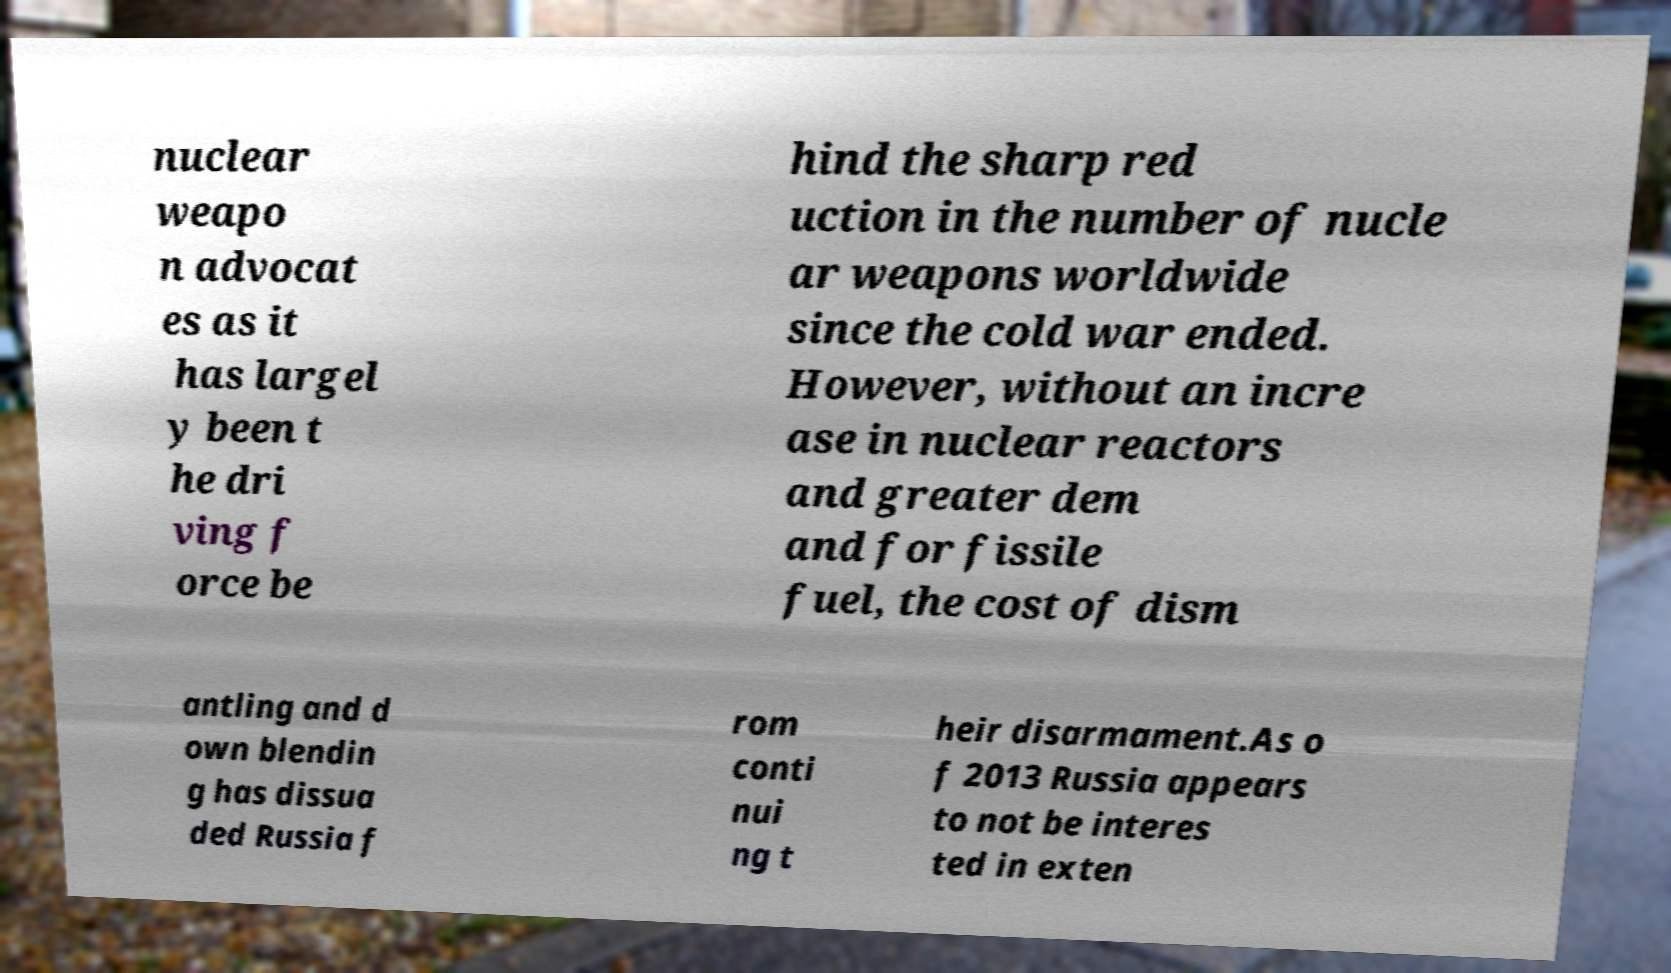I need the written content from this picture converted into text. Can you do that? nuclear weapo n advocat es as it has largel y been t he dri ving f orce be hind the sharp red uction in the number of nucle ar weapons worldwide since the cold war ended. However, without an incre ase in nuclear reactors and greater dem and for fissile fuel, the cost of dism antling and d own blendin g has dissua ded Russia f rom conti nui ng t heir disarmament.As o f 2013 Russia appears to not be interes ted in exten 